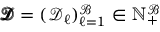<formula> <loc_0><loc_0><loc_500><loc_500>\pm b { \mathcal { D } } = ( \mathcal { D } _ { \ell } ) _ { \ell = 1 } ^ { \mathcal { B } } \in \mathbb { N } _ { + } ^ { \mathcal { B } }</formula> 